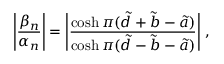Convert formula to latex. <formula><loc_0><loc_0><loc_500><loc_500>\left | \frac { \beta _ { n } } { \alpha _ { n } } \right | = \left | \frac { \cosh \pi ( \tilde { d } + \tilde { b } - \tilde { a } ) } { \cosh \pi ( \tilde { d } - \tilde { b } - \tilde { a } ) } \right | \, ,</formula> 